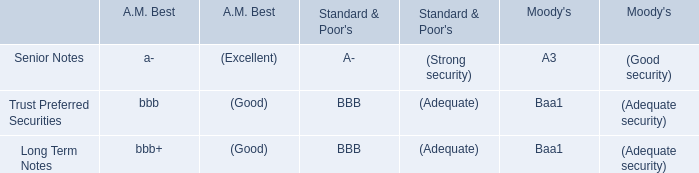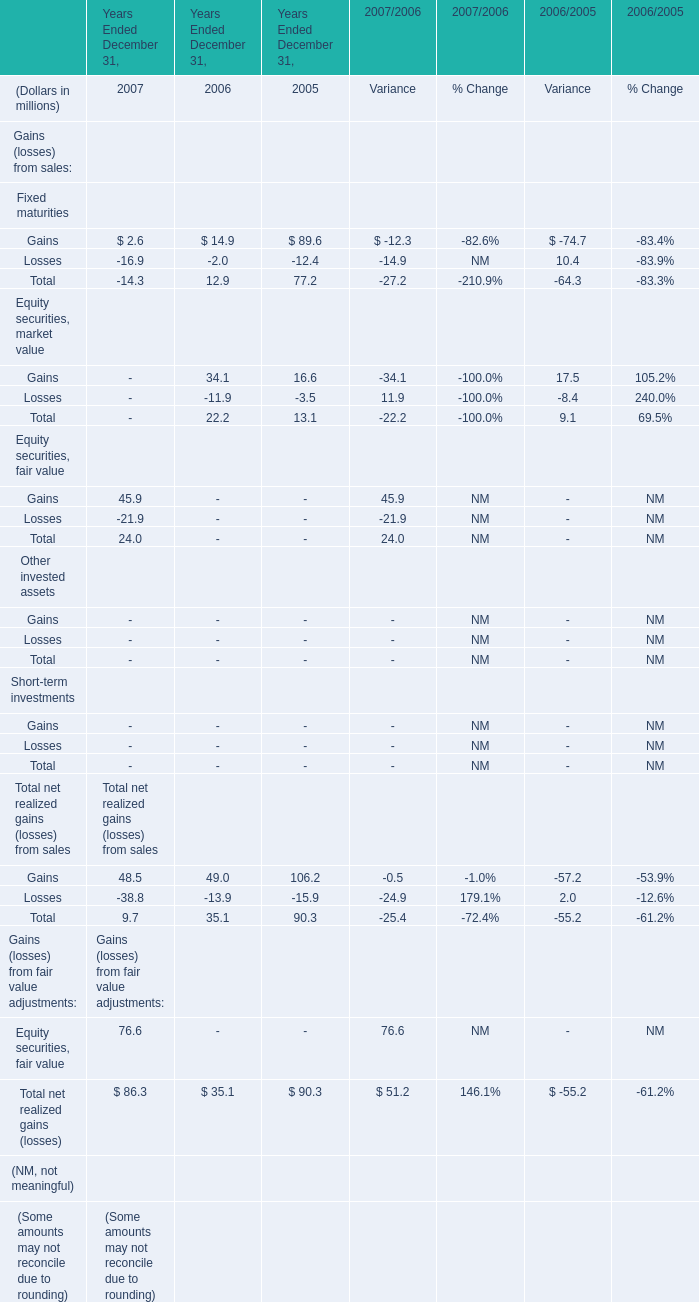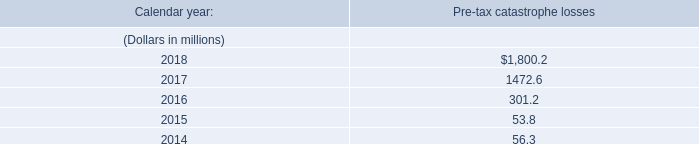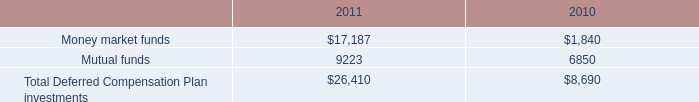Which element makes up more than 40 % of the total in 2006? 
Answer: Gains for Fixed maturities, Gains for Equity securities, market value. 